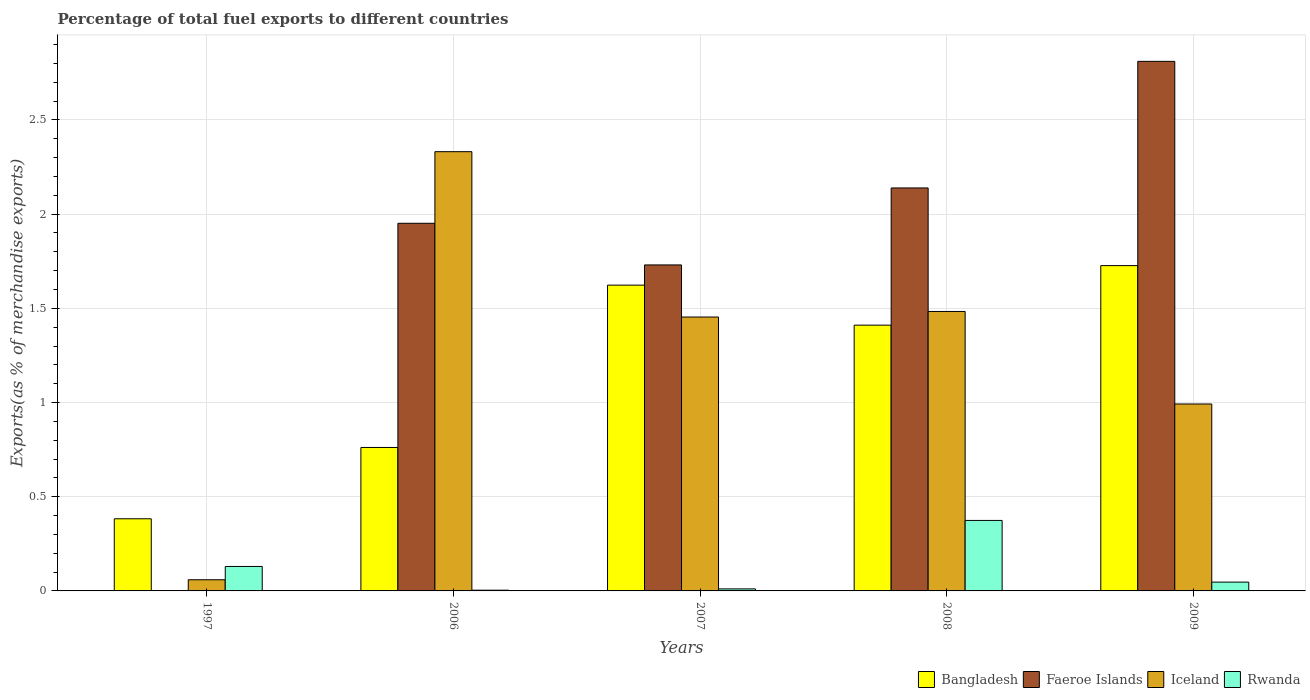How many different coloured bars are there?
Keep it short and to the point. 4. Are the number of bars on each tick of the X-axis equal?
Keep it short and to the point. Yes. What is the label of the 5th group of bars from the left?
Offer a very short reply. 2009. What is the percentage of exports to different countries in Bangladesh in 2006?
Your response must be concise. 0.76. Across all years, what is the maximum percentage of exports to different countries in Bangladesh?
Give a very brief answer. 1.73. Across all years, what is the minimum percentage of exports to different countries in Bangladesh?
Give a very brief answer. 0.38. What is the total percentage of exports to different countries in Bangladesh in the graph?
Your response must be concise. 5.9. What is the difference between the percentage of exports to different countries in Rwanda in 1997 and that in 2008?
Your answer should be compact. -0.24. What is the difference between the percentage of exports to different countries in Rwanda in 2008 and the percentage of exports to different countries in Bangladesh in 2009?
Ensure brevity in your answer.  -1.35. What is the average percentage of exports to different countries in Rwanda per year?
Your answer should be compact. 0.11. In the year 2006, what is the difference between the percentage of exports to different countries in Rwanda and percentage of exports to different countries in Faeroe Islands?
Your answer should be very brief. -1.95. What is the ratio of the percentage of exports to different countries in Faeroe Islands in 2007 to that in 2008?
Your answer should be compact. 0.81. Is the percentage of exports to different countries in Faeroe Islands in 1997 less than that in 2009?
Provide a succinct answer. Yes. Is the difference between the percentage of exports to different countries in Rwanda in 1997 and 2007 greater than the difference between the percentage of exports to different countries in Faeroe Islands in 1997 and 2007?
Offer a very short reply. Yes. What is the difference between the highest and the second highest percentage of exports to different countries in Faeroe Islands?
Your answer should be very brief. 0.67. What is the difference between the highest and the lowest percentage of exports to different countries in Iceland?
Offer a terse response. 2.27. Is the sum of the percentage of exports to different countries in Bangladesh in 2006 and 2007 greater than the maximum percentage of exports to different countries in Iceland across all years?
Provide a short and direct response. Yes. Is it the case that in every year, the sum of the percentage of exports to different countries in Bangladesh and percentage of exports to different countries in Iceland is greater than the sum of percentage of exports to different countries in Faeroe Islands and percentage of exports to different countries in Rwanda?
Your response must be concise. No. What does the 2nd bar from the left in 2006 represents?
Make the answer very short. Faeroe Islands. What does the 4th bar from the right in 2006 represents?
Keep it short and to the point. Bangladesh. How many bars are there?
Offer a very short reply. 20. Does the graph contain grids?
Your answer should be very brief. Yes. Where does the legend appear in the graph?
Give a very brief answer. Bottom right. What is the title of the graph?
Provide a succinct answer. Percentage of total fuel exports to different countries. Does "Tuvalu" appear as one of the legend labels in the graph?
Make the answer very short. No. What is the label or title of the X-axis?
Offer a terse response. Years. What is the label or title of the Y-axis?
Give a very brief answer. Exports(as % of merchandise exports). What is the Exports(as % of merchandise exports) of Bangladesh in 1997?
Ensure brevity in your answer.  0.38. What is the Exports(as % of merchandise exports) of Faeroe Islands in 1997?
Make the answer very short. 0. What is the Exports(as % of merchandise exports) of Iceland in 1997?
Offer a terse response. 0.06. What is the Exports(as % of merchandise exports) in Rwanda in 1997?
Provide a short and direct response. 0.13. What is the Exports(as % of merchandise exports) of Bangladesh in 2006?
Provide a succinct answer. 0.76. What is the Exports(as % of merchandise exports) of Faeroe Islands in 2006?
Keep it short and to the point. 1.95. What is the Exports(as % of merchandise exports) in Iceland in 2006?
Give a very brief answer. 2.33. What is the Exports(as % of merchandise exports) of Rwanda in 2006?
Keep it short and to the point. 0. What is the Exports(as % of merchandise exports) of Bangladesh in 2007?
Provide a succinct answer. 1.62. What is the Exports(as % of merchandise exports) in Faeroe Islands in 2007?
Your answer should be compact. 1.73. What is the Exports(as % of merchandise exports) of Iceland in 2007?
Provide a short and direct response. 1.45. What is the Exports(as % of merchandise exports) in Rwanda in 2007?
Give a very brief answer. 0.01. What is the Exports(as % of merchandise exports) in Bangladesh in 2008?
Keep it short and to the point. 1.41. What is the Exports(as % of merchandise exports) in Faeroe Islands in 2008?
Your answer should be compact. 2.14. What is the Exports(as % of merchandise exports) of Iceland in 2008?
Your answer should be very brief. 1.48. What is the Exports(as % of merchandise exports) in Rwanda in 2008?
Make the answer very short. 0.37. What is the Exports(as % of merchandise exports) in Bangladesh in 2009?
Your answer should be compact. 1.73. What is the Exports(as % of merchandise exports) of Faeroe Islands in 2009?
Offer a very short reply. 2.81. What is the Exports(as % of merchandise exports) in Iceland in 2009?
Your answer should be very brief. 0.99. What is the Exports(as % of merchandise exports) in Rwanda in 2009?
Your response must be concise. 0.05. Across all years, what is the maximum Exports(as % of merchandise exports) in Bangladesh?
Make the answer very short. 1.73. Across all years, what is the maximum Exports(as % of merchandise exports) in Faeroe Islands?
Give a very brief answer. 2.81. Across all years, what is the maximum Exports(as % of merchandise exports) of Iceland?
Your answer should be compact. 2.33. Across all years, what is the maximum Exports(as % of merchandise exports) of Rwanda?
Ensure brevity in your answer.  0.37. Across all years, what is the minimum Exports(as % of merchandise exports) of Bangladesh?
Offer a terse response. 0.38. Across all years, what is the minimum Exports(as % of merchandise exports) of Faeroe Islands?
Make the answer very short. 0. Across all years, what is the minimum Exports(as % of merchandise exports) in Iceland?
Offer a terse response. 0.06. Across all years, what is the minimum Exports(as % of merchandise exports) of Rwanda?
Offer a very short reply. 0. What is the total Exports(as % of merchandise exports) in Bangladesh in the graph?
Ensure brevity in your answer.  5.9. What is the total Exports(as % of merchandise exports) of Faeroe Islands in the graph?
Ensure brevity in your answer.  8.63. What is the total Exports(as % of merchandise exports) in Iceland in the graph?
Your answer should be very brief. 6.32. What is the total Exports(as % of merchandise exports) of Rwanda in the graph?
Ensure brevity in your answer.  0.57. What is the difference between the Exports(as % of merchandise exports) in Bangladesh in 1997 and that in 2006?
Your answer should be compact. -0.38. What is the difference between the Exports(as % of merchandise exports) in Faeroe Islands in 1997 and that in 2006?
Offer a very short reply. -1.95. What is the difference between the Exports(as % of merchandise exports) of Iceland in 1997 and that in 2006?
Offer a very short reply. -2.27. What is the difference between the Exports(as % of merchandise exports) in Rwanda in 1997 and that in 2006?
Offer a very short reply. 0.13. What is the difference between the Exports(as % of merchandise exports) in Bangladesh in 1997 and that in 2007?
Make the answer very short. -1.24. What is the difference between the Exports(as % of merchandise exports) of Faeroe Islands in 1997 and that in 2007?
Make the answer very short. -1.73. What is the difference between the Exports(as % of merchandise exports) of Iceland in 1997 and that in 2007?
Ensure brevity in your answer.  -1.39. What is the difference between the Exports(as % of merchandise exports) in Rwanda in 1997 and that in 2007?
Your response must be concise. 0.12. What is the difference between the Exports(as % of merchandise exports) of Bangladesh in 1997 and that in 2008?
Provide a succinct answer. -1.03. What is the difference between the Exports(as % of merchandise exports) in Faeroe Islands in 1997 and that in 2008?
Make the answer very short. -2.14. What is the difference between the Exports(as % of merchandise exports) of Iceland in 1997 and that in 2008?
Make the answer very short. -1.42. What is the difference between the Exports(as % of merchandise exports) of Rwanda in 1997 and that in 2008?
Make the answer very short. -0.24. What is the difference between the Exports(as % of merchandise exports) of Bangladesh in 1997 and that in 2009?
Provide a succinct answer. -1.34. What is the difference between the Exports(as % of merchandise exports) of Faeroe Islands in 1997 and that in 2009?
Your answer should be compact. -2.81. What is the difference between the Exports(as % of merchandise exports) in Iceland in 1997 and that in 2009?
Your response must be concise. -0.93. What is the difference between the Exports(as % of merchandise exports) of Rwanda in 1997 and that in 2009?
Provide a succinct answer. 0.08. What is the difference between the Exports(as % of merchandise exports) of Bangladesh in 2006 and that in 2007?
Provide a succinct answer. -0.86. What is the difference between the Exports(as % of merchandise exports) of Faeroe Islands in 2006 and that in 2007?
Offer a very short reply. 0.22. What is the difference between the Exports(as % of merchandise exports) of Iceland in 2006 and that in 2007?
Keep it short and to the point. 0.88. What is the difference between the Exports(as % of merchandise exports) of Rwanda in 2006 and that in 2007?
Give a very brief answer. -0.01. What is the difference between the Exports(as % of merchandise exports) in Bangladesh in 2006 and that in 2008?
Your answer should be compact. -0.65. What is the difference between the Exports(as % of merchandise exports) of Faeroe Islands in 2006 and that in 2008?
Your answer should be very brief. -0.19. What is the difference between the Exports(as % of merchandise exports) in Iceland in 2006 and that in 2008?
Offer a terse response. 0.85. What is the difference between the Exports(as % of merchandise exports) of Rwanda in 2006 and that in 2008?
Offer a very short reply. -0.37. What is the difference between the Exports(as % of merchandise exports) of Bangladesh in 2006 and that in 2009?
Provide a succinct answer. -0.97. What is the difference between the Exports(as % of merchandise exports) of Faeroe Islands in 2006 and that in 2009?
Provide a succinct answer. -0.86. What is the difference between the Exports(as % of merchandise exports) of Iceland in 2006 and that in 2009?
Keep it short and to the point. 1.34. What is the difference between the Exports(as % of merchandise exports) of Rwanda in 2006 and that in 2009?
Your answer should be very brief. -0.04. What is the difference between the Exports(as % of merchandise exports) in Bangladesh in 2007 and that in 2008?
Your answer should be compact. 0.21. What is the difference between the Exports(as % of merchandise exports) in Faeroe Islands in 2007 and that in 2008?
Offer a very short reply. -0.41. What is the difference between the Exports(as % of merchandise exports) in Iceland in 2007 and that in 2008?
Your response must be concise. -0.03. What is the difference between the Exports(as % of merchandise exports) in Rwanda in 2007 and that in 2008?
Provide a short and direct response. -0.36. What is the difference between the Exports(as % of merchandise exports) in Bangladesh in 2007 and that in 2009?
Your answer should be very brief. -0.1. What is the difference between the Exports(as % of merchandise exports) of Faeroe Islands in 2007 and that in 2009?
Your answer should be very brief. -1.08. What is the difference between the Exports(as % of merchandise exports) of Iceland in 2007 and that in 2009?
Offer a terse response. 0.46. What is the difference between the Exports(as % of merchandise exports) in Rwanda in 2007 and that in 2009?
Provide a short and direct response. -0.04. What is the difference between the Exports(as % of merchandise exports) in Bangladesh in 2008 and that in 2009?
Your answer should be compact. -0.32. What is the difference between the Exports(as % of merchandise exports) in Faeroe Islands in 2008 and that in 2009?
Provide a short and direct response. -0.67. What is the difference between the Exports(as % of merchandise exports) in Iceland in 2008 and that in 2009?
Give a very brief answer. 0.49. What is the difference between the Exports(as % of merchandise exports) of Rwanda in 2008 and that in 2009?
Provide a short and direct response. 0.33. What is the difference between the Exports(as % of merchandise exports) in Bangladesh in 1997 and the Exports(as % of merchandise exports) in Faeroe Islands in 2006?
Offer a terse response. -1.57. What is the difference between the Exports(as % of merchandise exports) of Bangladesh in 1997 and the Exports(as % of merchandise exports) of Iceland in 2006?
Provide a succinct answer. -1.95. What is the difference between the Exports(as % of merchandise exports) of Bangladesh in 1997 and the Exports(as % of merchandise exports) of Rwanda in 2006?
Make the answer very short. 0.38. What is the difference between the Exports(as % of merchandise exports) in Faeroe Islands in 1997 and the Exports(as % of merchandise exports) in Iceland in 2006?
Your response must be concise. -2.33. What is the difference between the Exports(as % of merchandise exports) of Faeroe Islands in 1997 and the Exports(as % of merchandise exports) of Rwanda in 2006?
Your answer should be compact. -0. What is the difference between the Exports(as % of merchandise exports) in Iceland in 1997 and the Exports(as % of merchandise exports) in Rwanda in 2006?
Keep it short and to the point. 0.06. What is the difference between the Exports(as % of merchandise exports) of Bangladesh in 1997 and the Exports(as % of merchandise exports) of Faeroe Islands in 2007?
Offer a terse response. -1.35. What is the difference between the Exports(as % of merchandise exports) in Bangladesh in 1997 and the Exports(as % of merchandise exports) in Iceland in 2007?
Provide a succinct answer. -1.07. What is the difference between the Exports(as % of merchandise exports) of Bangladesh in 1997 and the Exports(as % of merchandise exports) of Rwanda in 2007?
Offer a terse response. 0.37. What is the difference between the Exports(as % of merchandise exports) of Faeroe Islands in 1997 and the Exports(as % of merchandise exports) of Iceland in 2007?
Your answer should be compact. -1.45. What is the difference between the Exports(as % of merchandise exports) in Faeroe Islands in 1997 and the Exports(as % of merchandise exports) in Rwanda in 2007?
Ensure brevity in your answer.  -0.01. What is the difference between the Exports(as % of merchandise exports) of Iceland in 1997 and the Exports(as % of merchandise exports) of Rwanda in 2007?
Provide a succinct answer. 0.05. What is the difference between the Exports(as % of merchandise exports) in Bangladesh in 1997 and the Exports(as % of merchandise exports) in Faeroe Islands in 2008?
Give a very brief answer. -1.76. What is the difference between the Exports(as % of merchandise exports) in Bangladesh in 1997 and the Exports(as % of merchandise exports) in Iceland in 2008?
Make the answer very short. -1.1. What is the difference between the Exports(as % of merchandise exports) of Bangladesh in 1997 and the Exports(as % of merchandise exports) of Rwanda in 2008?
Give a very brief answer. 0.01. What is the difference between the Exports(as % of merchandise exports) in Faeroe Islands in 1997 and the Exports(as % of merchandise exports) in Iceland in 2008?
Provide a short and direct response. -1.48. What is the difference between the Exports(as % of merchandise exports) of Faeroe Islands in 1997 and the Exports(as % of merchandise exports) of Rwanda in 2008?
Your answer should be very brief. -0.37. What is the difference between the Exports(as % of merchandise exports) in Iceland in 1997 and the Exports(as % of merchandise exports) in Rwanda in 2008?
Provide a succinct answer. -0.31. What is the difference between the Exports(as % of merchandise exports) in Bangladesh in 1997 and the Exports(as % of merchandise exports) in Faeroe Islands in 2009?
Give a very brief answer. -2.43. What is the difference between the Exports(as % of merchandise exports) in Bangladesh in 1997 and the Exports(as % of merchandise exports) in Iceland in 2009?
Give a very brief answer. -0.61. What is the difference between the Exports(as % of merchandise exports) in Bangladesh in 1997 and the Exports(as % of merchandise exports) in Rwanda in 2009?
Ensure brevity in your answer.  0.34. What is the difference between the Exports(as % of merchandise exports) of Faeroe Islands in 1997 and the Exports(as % of merchandise exports) of Iceland in 2009?
Your answer should be compact. -0.99. What is the difference between the Exports(as % of merchandise exports) in Faeroe Islands in 1997 and the Exports(as % of merchandise exports) in Rwanda in 2009?
Keep it short and to the point. -0.05. What is the difference between the Exports(as % of merchandise exports) in Iceland in 1997 and the Exports(as % of merchandise exports) in Rwanda in 2009?
Your answer should be very brief. 0.01. What is the difference between the Exports(as % of merchandise exports) in Bangladesh in 2006 and the Exports(as % of merchandise exports) in Faeroe Islands in 2007?
Ensure brevity in your answer.  -0.97. What is the difference between the Exports(as % of merchandise exports) of Bangladesh in 2006 and the Exports(as % of merchandise exports) of Iceland in 2007?
Your response must be concise. -0.69. What is the difference between the Exports(as % of merchandise exports) of Bangladesh in 2006 and the Exports(as % of merchandise exports) of Rwanda in 2007?
Provide a short and direct response. 0.75. What is the difference between the Exports(as % of merchandise exports) of Faeroe Islands in 2006 and the Exports(as % of merchandise exports) of Iceland in 2007?
Keep it short and to the point. 0.5. What is the difference between the Exports(as % of merchandise exports) of Faeroe Islands in 2006 and the Exports(as % of merchandise exports) of Rwanda in 2007?
Provide a succinct answer. 1.94. What is the difference between the Exports(as % of merchandise exports) in Iceland in 2006 and the Exports(as % of merchandise exports) in Rwanda in 2007?
Your answer should be compact. 2.32. What is the difference between the Exports(as % of merchandise exports) in Bangladesh in 2006 and the Exports(as % of merchandise exports) in Faeroe Islands in 2008?
Ensure brevity in your answer.  -1.38. What is the difference between the Exports(as % of merchandise exports) of Bangladesh in 2006 and the Exports(as % of merchandise exports) of Iceland in 2008?
Keep it short and to the point. -0.72. What is the difference between the Exports(as % of merchandise exports) in Bangladesh in 2006 and the Exports(as % of merchandise exports) in Rwanda in 2008?
Provide a succinct answer. 0.39. What is the difference between the Exports(as % of merchandise exports) of Faeroe Islands in 2006 and the Exports(as % of merchandise exports) of Iceland in 2008?
Offer a terse response. 0.47. What is the difference between the Exports(as % of merchandise exports) in Faeroe Islands in 2006 and the Exports(as % of merchandise exports) in Rwanda in 2008?
Offer a very short reply. 1.58. What is the difference between the Exports(as % of merchandise exports) in Iceland in 2006 and the Exports(as % of merchandise exports) in Rwanda in 2008?
Make the answer very short. 1.96. What is the difference between the Exports(as % of merchandise exports) in Bangladesh in 2006 and the Exports(as % of merchandise exports) in Faeroe Islands in 2009?
Offer a very short reply. -2.05. What is the difference between the Exports(as % of merchandise exports) in Bangladesh in 2006 and the Exports(as % of merchandise exports) in Iceland in 2009?
Your answer should be compact. -0.23. What is the difference between the Exports(as % of merchandise exports) of Bangladesh in 2006 and the Exports(as % of merchandise exports) of Rwanda in 2009?
Your response must be concise. 0.71. What is the difference between the Exports(as % of merchandise exports) in Faeroe Islands in 2006 and the Exports(as % of merchandise exports) in Iceland in 2009?
Your answer should be compact. 0.96. What is the difference between the Exports(as % of merchandise exports) of Faeroe Islands in 2006 and the Exports(as % of merchandise exports) of Rwanda in 2009?
Your answer should be very brief. 1.9. What is the difference between the Exports(as % of merchandise exports) of Iceland in 2006 and the Exports(as % of merchandise exports) of Rwanda in 2009?
Offer a terse response. 2.28. What is the difference between the Exports(as % of merchandise exports) in Bangladesh in 2007 and the Exports(as % of merchandise exports) in Faeroe Islands in 2008?
Offer a terse response. -0.52. What is the difference between the Exports(as % of merchandise exports) of Bangladesh in 2007 and the Exports(as % of merchandise exports) of Iceland in 2008?
Offer a very short reply. 0.14. What is the difference between the Exports(as % of merchandise exports) in Bangladesh in 2007 and the Exports(as % of merchandise exports) in Rwanda in 2008?
Ensure brevity in your answer.  1.25. What is the difference between the Exports(as % of merchandise exports) of Faeroe Islands in 2007 and the Exports(as % of merchandise exports) of Iceland in 2008?
Ensure brevity in your answer.  0.25. What is the difference between the Exports(as % of merchandise exports) in Faeroe Islands in 2007 and the Exports(as % of merchandise exports) in Rwanda in 2008?
Your response must be concise. 1.36. What is the difference between the Exports(as % of merchandise exports) in Iceland in 2007 and the Exports(as % of merchandise exports) in Rwanda in 2008?
Provide a short and direct response. 1.08. What is the difference between the Exports(as % of merchandise exports) of Bangladesh in 2007 and the Exports(as % of merchandise exports) of Faeroe Islands in 2009?
Your response must be concise. -1.19. What is the difference between the Exports(as % of merchandise exports) in Bangladesh in 2007 and the Exports(as % of merchandise exports) in Iceland in 2009?
Provide a short and direct response. 0.63. What is the difference between the Exports(as % of merchandise exports) in Bangladesh in 2007 and the Exports(as % of merchandise exports) in Rwanda in 2009?
Provide a succinct answer. 1.58. What is the difference between the Exports(as % of merchandise exports) of Faeroe Islands in 2007 and the Exports(as % of merchandise exports) of Iceland in 2009?
Give a very brief answer. 0.74. What is the difference between the Exports(as % of merchandise exports) of Faeroe Islands in 2007 and the Exports(as % of merchandise exports) of Rwanda in 2009?
Make the answer very short. 1.68. What is the difference between the Exports(as % of merchandise exports) of Iceland in 2007 and the Exports(as % of merchandise exports) of Rwanda in 2009?
Provide a succinct answer. 1.41. What is the difference between the Exports(as % of merchandise exports) of Bangladesh in 2008 and the Exports(as % of merchandise exports) of Faeroe Islands in 2009?
Ensure brevity in your answer.  -1.4. What is the difference between the Exports(as % of merchandise exports) of Bangladesh in 2008 and the Exports(as % of merchandise exports) of Iceland in 2009?
Provide a succinct answer. 0.42. What is the difference between the Exports(as % of merchandise exports) in Bangladesh in 2008 and the Exports(as % of merchandise exports) in Rwanda in 2009?
Ensure brevity in your answer.  1.36. What is the difference between the Exports(as % of merchandise exports) of Faeroe Islands in 2008 and the Exports(as % of merchandise exports) of Iceland in 2009?
Make the answer very short. 1.15. What is the difference between the Exports(as % of merchandise exports) of Faeroe Islands in 2008 and the Exports(as % of merchandise exports) of Rwanda in 2009?
Your answer should be very brief. 2.09. What is the difference between the Exports(as % of merchandise exports) in Iceland in 2008 and the Exports(as % of merchandise exports) in Rwanda in 2009?
Provide a short and direct response. 1.44. What is the average Exports(as % of merchandise exports) of Bangladesh per year?
Offer a terse response. 1.18. What is the average Exports(as % of merchandise exports) in Faeroe Islands per year?
Provide a short and direct response. 1.73. What is the average Exports(as % of merchandise exports) in Iceland per year?
Your answer should be compact. 1.26. What is the average Exports(as % of merchandise exports) in Rwanda per year?
Keep it short and to the point. 0.11. In the year 1997, what is the difference between the Exports(as % of merchandise exports) in Bangladesh and Exports(as % of merchandise exports) in Faeroe Islands?
Offer a terse response. 0.38. In the year 1997, what is the difference between the Exports(as % of merchandise exports) in Bangladesh and Exports(as % of merchandise exports) in Iceland?
Offer a very short reply. 0.32. In the year 1997, what is the difference between the Exports(as % of merchandise exports) of Bangladesh and Exports(as % of merchandise exports) of Rwanda?
Offer a very short reply. 0.25. In the year 1997, what is the difference between the Exports(as % of merchandise exports) of Faeroe Islands and Exports(as % of merchandise exports) of Iceland?
Your response must be concise. -0.06. In the year 1997, what is the difference between the Exports(as % of merchandise exports) of Faeroe Islands and Exports(as % of merchandise exports) of Rwanda?
Give a very brief answer. -0.13. In the year 1997, what is the difference between the Exports(as % of merchandise exports) in Iceland and Exports(as % of merchandise exports) in Rwanda?
Your response must be concise. -0.07. In the year 2006, what is the difference between the Exports(as % of merchandise exports) in Bangladesh and Exports(as % of merchandise exports) in Faeroe Islands?
Your answer should be compact. -1.19. In the year 2006, what is the difference between the Exports(as % of merchandise exports) of Bangladesh and Exports(as % of merchandise exports) of Iceland?
Your response must be concise. -1.57. In the year 2006, what is the difference between the Exports(as % of merchandise exports) of Bangladesh and Exports(as % of merchandise exports) of Rwanda?
Keep it short and to the point. 0.76. In the year 2006, what is the difference between the Exports(as % of merchandise exports) of Faeroe Islands and Exports(as % of merchandise exports) of Iceland?
Your answer should be compact. -0.38. In the year 2006, what is the difference between the Exports(as % of merchandise exports) of Faeroe Islands and Exports(as % of merchandise exports) of Rwanda?
Ensure brevity in your answer.  1.95. In the year 2006, what is the difference between the Exports(as % of merchandise exports) of Iceland and Exports(as % of merchandise exports) of Rwanda?
Provide a short and direct response. 2.33. In the year 2007, what is the difference between the Exports(as % of merchandise exports) of Bangladesh and Exports(as % of merchandise exports) of Faeroe Islands?
Offer a terse response. -0.11. In the year 2007, what is the difference between the Exports(as % of merchandise exports) of Bangladesh and Exports(as % of merchandise exports) of Iceland?
Ensure brevity in your answer.  0.17. In the year 2007, what is the difference between the Exports(as % of merchandise exports) in Bangladesh and Exports(as % of merchandise exports) in Rwanda?
Offer a very short reply. 1.61. In the year 2007, what is the difference between the Exports(as % of merchandise exports) in Faeroe Islands and Exports(as % of merchandise exports) in Iceland?
Keep it short and to the point. 0.28. In the year 2007, what is the difference between the Exports(as % of merchandise exports) of Faeroe Islands and Exports(as % of merchandise exports) of Rwanda?
Provide a short and direct response. 1.72. In the year 2007, what is the difference between the Exports(as % of merchandise exports) in Iceland and Exports(as % of merchandise exports) in Rwanda?
Your answer should be very brief. 1.44. In the year 2008, what is the difference between the Exports(as % of merchandise exports) of Bangladesh and Exports(as % of merchandise exports) of Faeroe Islands?
Provide a succinct answer. -0.73. In the year 2008, what is the difference between the Exports(as % of merchandise exports) in Bangladesh and Exports(as % of merchandise exports) in Iceland?
Keep it short and to the point. -0.07. In the year 2008, what is the difference between the Exports(as % of merchandise exports) of Bangladesh and Exports(as % of merchandise exports) of Rwanda?
Give a very brief answer. 1.04. In the year 2008, what is the difference between the Exports(as % of merchandise exports) of Faeroe Islands and Exports(as % of merchandise exports) of Iceland?
Your response must be concise. 0.66. In the year 2008, what is the difference between the Exports(as % of merchandise exports) in Faeroe Islands and Exports(as % of merchandise exports) in Rwanda?
Provide a short and direct response. 1.76. In the year 2008, what is the difference between the Exports(as % of merchandise exports) in Iceland and Exports(as % of merchandise exports) in Rwanda?
Provide a succinct answer. 1.11. In the year 2009, what is the difference between the Exports(as % of merchandise exports) of Bangladesh and Exports(as % of merchandise exports) of Faeroe Islands?
Offer a very short reply. -1.08. In the year 2009, what is the difference between the Exports(as % of merchandise exports) in Bangladesh and Exports(as % of merchandise exports) in Iceland?
Offer a terse response. 0.73. In the year 2009, what is the difference between the Exports(as % of merchandise exports) of Bangladesh and Exports(as % of merchandise exports) of Rwanda?
Keep it short and to the point. 1.68. In the year 2009, what is the difference between the Exports(as % of merchandise exports) in Faeroe Islands and Exports(as % of merchandise exports) in Iceland?
Ensure brevity in your answer.  1.82. In the year 2009, what is the difference between the Exports(as % of merchandise exports) of Faeroe Islands and Exports(as % of merchandise exports) of Rwanda?
Your answer should be very brief. 2.76. In the year 2009, what is the difference between the Exports(as % of merchandise exports) in Iceland and Exports(as % of merchandise exports) in Rwanda?
Offer a very short reply. 0.95. What is the ratio of the Exports(as % of merchandise exports) of Bangladesh in 1997 to that in 2006?
Make the answer very short. 0.5. What is the ratio of the Exports(as % of merchandise exports) of Iceland in 1997 to that in 2006?
Offer a terse response. 0.03. What is the ratio of the Exports(as % of merchandise exports) of Rwanda in 1997 to that in 2006?
Keep it short and to the point. 33.54. What is the ratio of the Exports(as % of merchandise exports) in Bangladesh in 1997 to that in 2007?
Provide a short and direct response. 0.24. What is the ratio of the Exports(as % of merchandise exports) of Faeroe Islands in 1997 to that in 2007?
Give a very brief answer. 0. What is the ratio of the Exports(as % of merchandise exports) of Iceland in 1997 to that in 2007?
Offer a very short reply. 0.04. What is the ratio of the Exports(as % of merchandise exports) of Rwanda in 1997 to that in 2007?
Provide a succinct answer. 11.98. What is the ratio of the Exports(as % of merchandise exports) in Bangladesh in 1997 to that in 2008?
Provide a short and direct response. 0.27. What is the ratio of the Exports(as % of merchandise exports) in Faeroe Islands in 1997 to that in 2008?
Offer a very short reply. 0. What is the ratio of the Exports(as % of merchandise exports) of Iceland in 1997 to that in 2008?
Provide a succinct answer. 0.04. What is the ratio of the Exports(as % of merchandise exports) in Rwanda in 1997 to that in 2008?
Keep it short and to the point. 0.35. What is the ratio of the Exports(as % of merchandise exports) in Bangladesh in 1997 to that in 2009?
Provide a short and direct response. 0.22. What is the ratio of the Exports(as % of merchandise exports) of Faeroe Islands in 1997 to that in 2009?
Offer a very short reply. 0. What is the ratio of the Exports(as % of merchandise exports) of Iceland in 1997 to that in 2009?
Give a very brief answer. 0.06. What is the ratio of the Exports(as % of merchandise exports) in Rwanda in 1997 to that in 2009?
Provide a succinct answer. 2.78. What is the ratio of the Exports(as % of merchandise exports) of Bangladesh in 2006 to that in 2007?
Offer a terse response. 0.47. What is the ratio of the Exports(as % of merchandise exports) of Faeroe Islands in 2006 to that in 2007?
Give a very brief answer. 1.13. What is the ratio of the Exports(as % of merchandise exports) in Iceland in 2006 to that in 2007?
Provide a succinct answer. 1.6. What is the ratio of the Exports(as % of merchandise exports) in Rwanda in 2006 to that in 2007?
Offer a terse response. 0.36. What is the ratio of the Exports(as % of merchandise exports) in Bangladesh in 2006 to that in 2008?
Provide a succinct answer. 0.54. What is the ratio of the Exports(as % of merchandise exports) of Faeroe Islands in 2006 to that in 2008?
Your answer should be compact. 0.91. What is the ratio of the Exports(as % of merchandise exports) in Iceland in 2006 to that in 2008?
Your answer should be very brief. 1.57. What is the ratio of the Exports(as % of merchandise exports) in Rwanda in 2006 to that in 2008?
Make the answer very short. 0.01. What is the ratio of the Exports(as % of merchandise exports) in Bangladesh in 2006 to that in 2009?
Ensure brevity in your answer.  0.44. What is the ratio of the Exports(as % of merchandise exports) of Faeroe Islands in 2006 to that in 2009?
Offer a terse response. 0.69. What is the ratio of the Exports(as % of merchandise exports) in Iceland in 2006 to that in 2009?
Keep it short and to the point. 2.35. What is the ratio of the Exports(as % of merchandise exports) of Rwanda in 2006 to that in 2009?
Keep it short and to the point. 0.08. What is the ratio of the Exports(as % of merchandise exports) of Bangladesh in 2007 to that in 2008?
Offer a terse response. 1.15. What is the ratio of the Exports(as % of merchandise exports) of Faeroe Islands in 2007 to that in 2008?
Make the answer very short. 0.81. What is the ratio of the Exports(as % of merchandise exports) of Iceland in 2007 to that in 2008?
Your response must be concise. 0.98. What is the ratio of the Exports(as % of merchandise exports) in Rwanda in 2007 to that in 2008?
Provide a short and direct response. 0.03. What is the ratio of the Exports(as % of merchandise exports) in Bangladesh in 2007 to that in 2009?
Your answer should be very brief. 0.94. What is the ratio of the Exports(as % of merchandise exports) in Faeroe Islands in 2007 to that in 2009?
Keep it short and to the point. 0.62. What is the ratio of the Exports(as % of merchandise exports) in Iceland in 2007 to that in 2009?
Provide a succinct answer. 1.47. What is the ratio of the Exports(as % of merchandise exports) in Rwanda in 2007 to that in 2009?
Make the answer very short. 0.23. What is the ratio of the Exports(as % of merchandise exports) of Bangladesh in 2008 to that in 2009?
Your answer should be compact. 0.82. What is the ratio of the Exports(as % of merchandise exports) in Faeroe Islands in 2008 to that in 2009?
Keep it short and to the point. 0.76. What is the ratio of the Exports(as % of merchandise exports) of Iceland in 2008 to that in 2009?
Your response must be concise. 1.5. What is the ratio of the Exports(as % of merchandise exports) of Rwanda in 2008 to that in 2009?
Give a very brief answer. 8.01. What is the difference between the highest and the second highest Exports(as % of merchandise exports) of Bangladesh?
Keep it short and to the point. 0.1. What is the difference between the highest and the second highest Exports(as % of merchandise exports) of Faeroe Islands?
Your response must be concise. 0.67. What is the difference between the highest and the second highest Exports(as % of merchandise exports) of Iceland?
Provide a short and direct response. 0.85. What is the difference between the highest and the second highest Exports(as % of merchandise exports) in Rwanda?
Keep it short and to the point. 0.24. What is the difference between the highest and the lowest Exports(as % of merchandise exports) of Bangladesh?
Provide a short and direct response. 1.34. What is the difference between the highest and the lowest Exports(as % of merchandise exports) of Faeroe Islands?
Offer a terse response. 2.81. What is the difference between the highest and the lowest Exports(as % of merchandise exports) in Iceland?
Keep it short and to the point. 2.27. What is the difference between the highest and the lowest Exports(as % of merchandise exports) of Rwanda?
Your answer should be very brief. 0.37. 